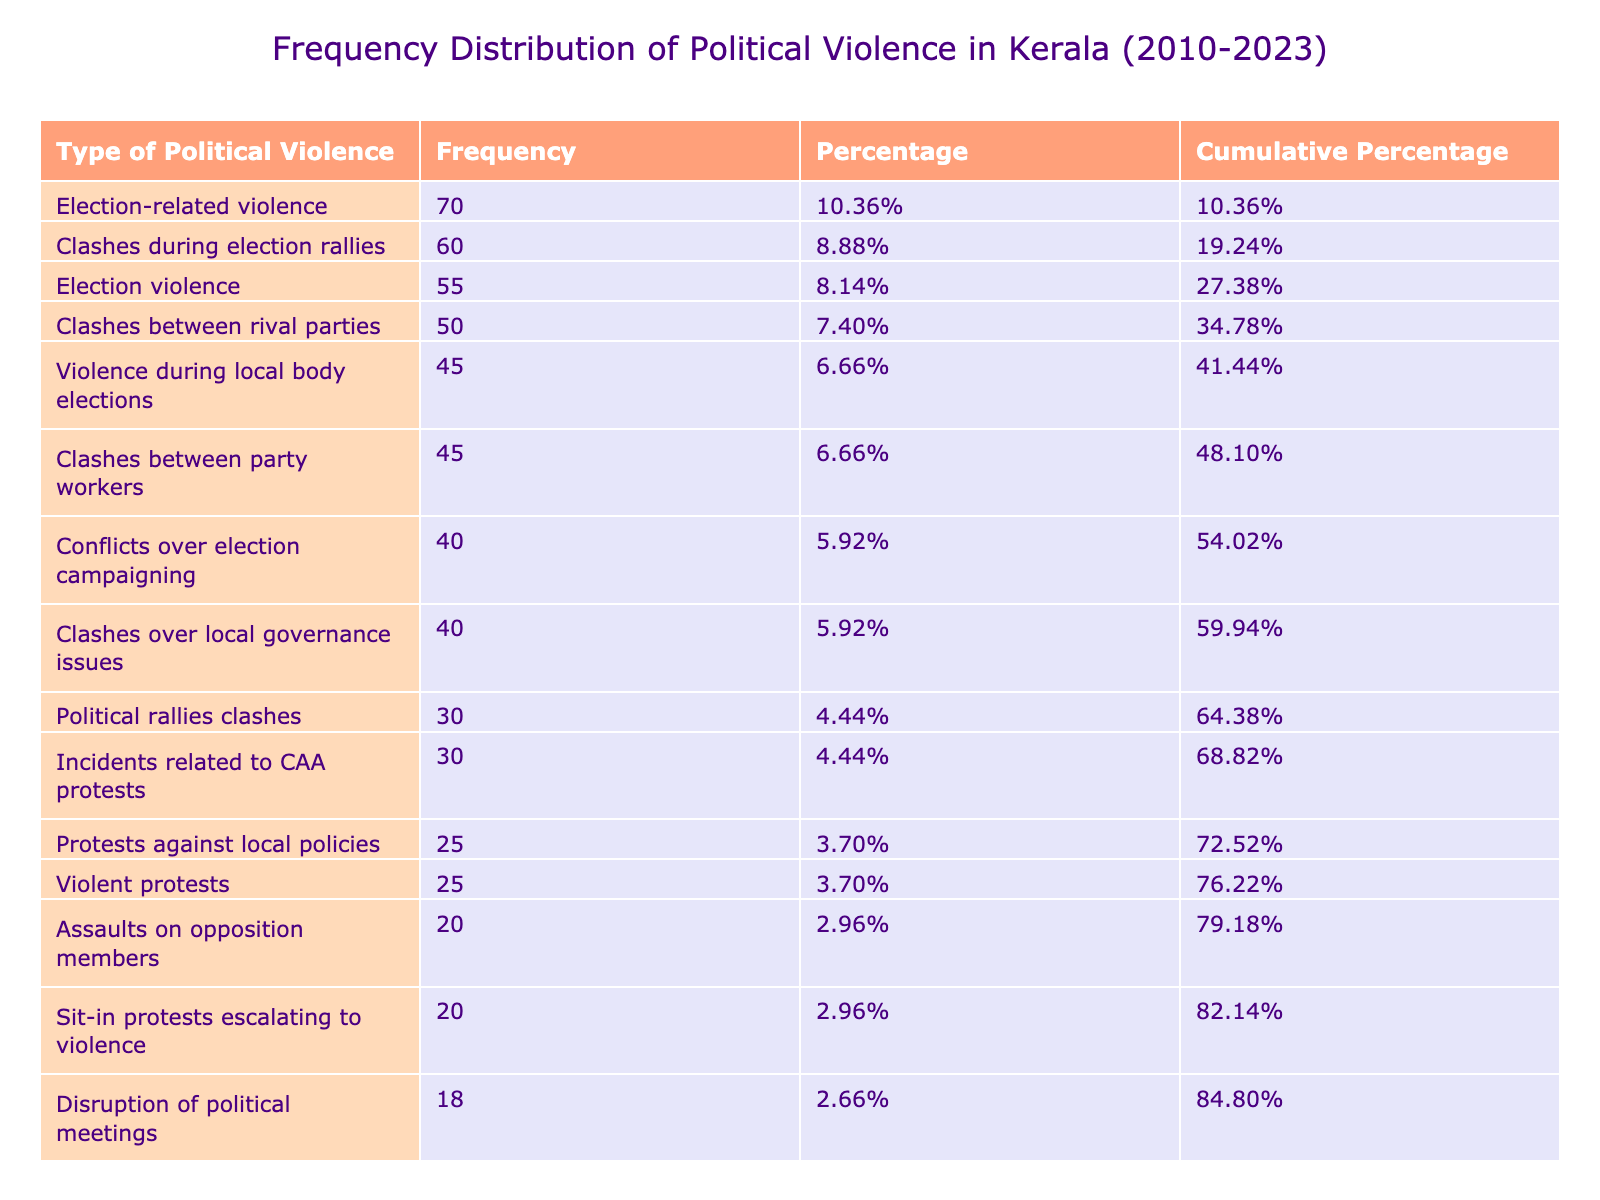What type of political violence has the highest number of incidents? By examining the table, we identify the types of political violence listed and compare their incident counts. The type with the highest number is "Election-related violence," with 70 incidents in 2018.
Answer: Election-related violence How many incidents were related to vandalism? To find the total number of vandalism incidents, we can sum the values for the related types: "Vandalism of political offices" (12), "Vandalism of party symbols" (10), and "Vandalism of educational institutions" (6). The total is 12 + 10 + 6 = 28.
Answer: 28 What percentage of incidents were from "Clashes during election rallies" compared to total incidents? The number of incidents from "Clashes during election rallies" is 60. To find the percentage, we first sum all incidents, which gives us a total of 477. Then, we calculate the percentage as (60 / 477) * 100, which equals approximately 12.57%.
Answer: 12.57% Is the number of incidents related to political assassinations greater than those from violent protests? In the table, the incidents for political assassinations (1) are substantially less than for violent protests (25). Thus, the statement is false.
Answer: No What is the cumulative percentage of incidents for the top three types of political violence? After calculating the percentages for the top three types (Election-related violence: 14.65%, Clashes during election rallies: 12.57%, and Clashes between rival parties: 10.49%), we find the cumulative percentage by adding these values together: 14.65 + 12.57 + 10.49 = 37.71%.
Answer: 37.71% What was the total number of political violence incidents reported in 2022? In 2022, the incidents consist of "Election violence" (55) and "Sit-in protests escalating to violence" (20). Summing these gives a total of 55 + 20 = 75 incidents in 2022.
Answer: 75 Which year had the least number of incidents overall? By comparing total incidents by year, we find that 2016 had the lowest total of 42 incidents (Assassination of political activists: 2 + Clashes over local governance issues: 40).
Answer: 2016 Was there an increase in violent protests from 2015 to 2020? The table shows 25 incidents of violent protests in 2015 and 25 in 2020, indicating no increase as the numbers are equal.
Answer: No 